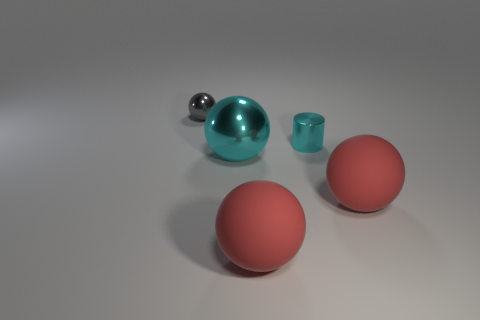What number of rubber objects are either large red things or small cyan objects?
Keep it short and to the point. 2. What number of small green spheres are there?
Offer a very short reply. 0. Is the small object that is behind the cylinder made of the same material as the tiny cyan thing that is behind the cyan sphere?
Offer a terse response. Yes. There is another metallic thing that is the same shape as the big metallic object; what color is it?
Your answer should be very brief. Gray. What material is the small object in front of the tiny gray object that is behind the small shiny cylinder?
Provide a succinct answer. Metal. Is the shape of the cyan shiny thing that is in front of the tiny cyan metallic object the same as the cyan shiny object right of the cyan ball?
Give a very brief answer. No. There is a object that is behind the large cyan ball and on the right side of the cyan ball; what is its size?
Keep it short and to the point. Small. What number of other things are there of the same color as the large metallic sphere?
Offer a terse response. 1. Does the big red thing that is right of the tiny cyan object have the same material as the cyan cylinder?
Provide a succinct answer. No. Are there fewer tiny cyan metallic objects that are in front of the cyan shiny cylinder than tiny cylinders that are in front of the gray metal sphere?
Your response must be concise. Yes. 